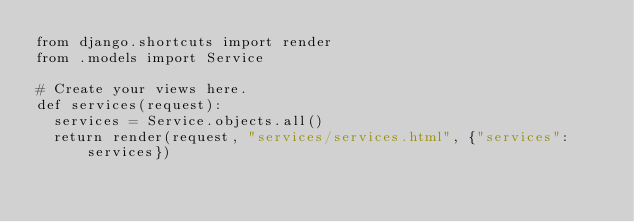Convert code to text. <code><loc_0><loc_0><loc_500><loc_500><_Python_>from django.shortcuts import render
from .models import Service

# Create your views here.
def services(request):
  services = Service.objects.all()
  return render(request, "services/services.html", {"services":services})</code> 